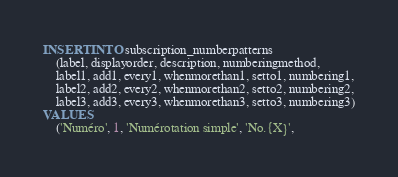Convert code to text. <code><loc_0><loc_0><loc_500><loc_500><_SQL_>INSERT INTO subscription_numberpatterns
    (label, displayorder, description, numberingmethod,
    label1, add1, every1, whenmorethan1, setto1, numbering1,
    label2, add2, every2, whenmorethan2, setto2, numbering2,
    label3, add3, every3, whenmorethan3, setto3, numbering3)
VALUES
    ('Numéro', 1, 'Numérotation simple', 'No.{X}',</code> 